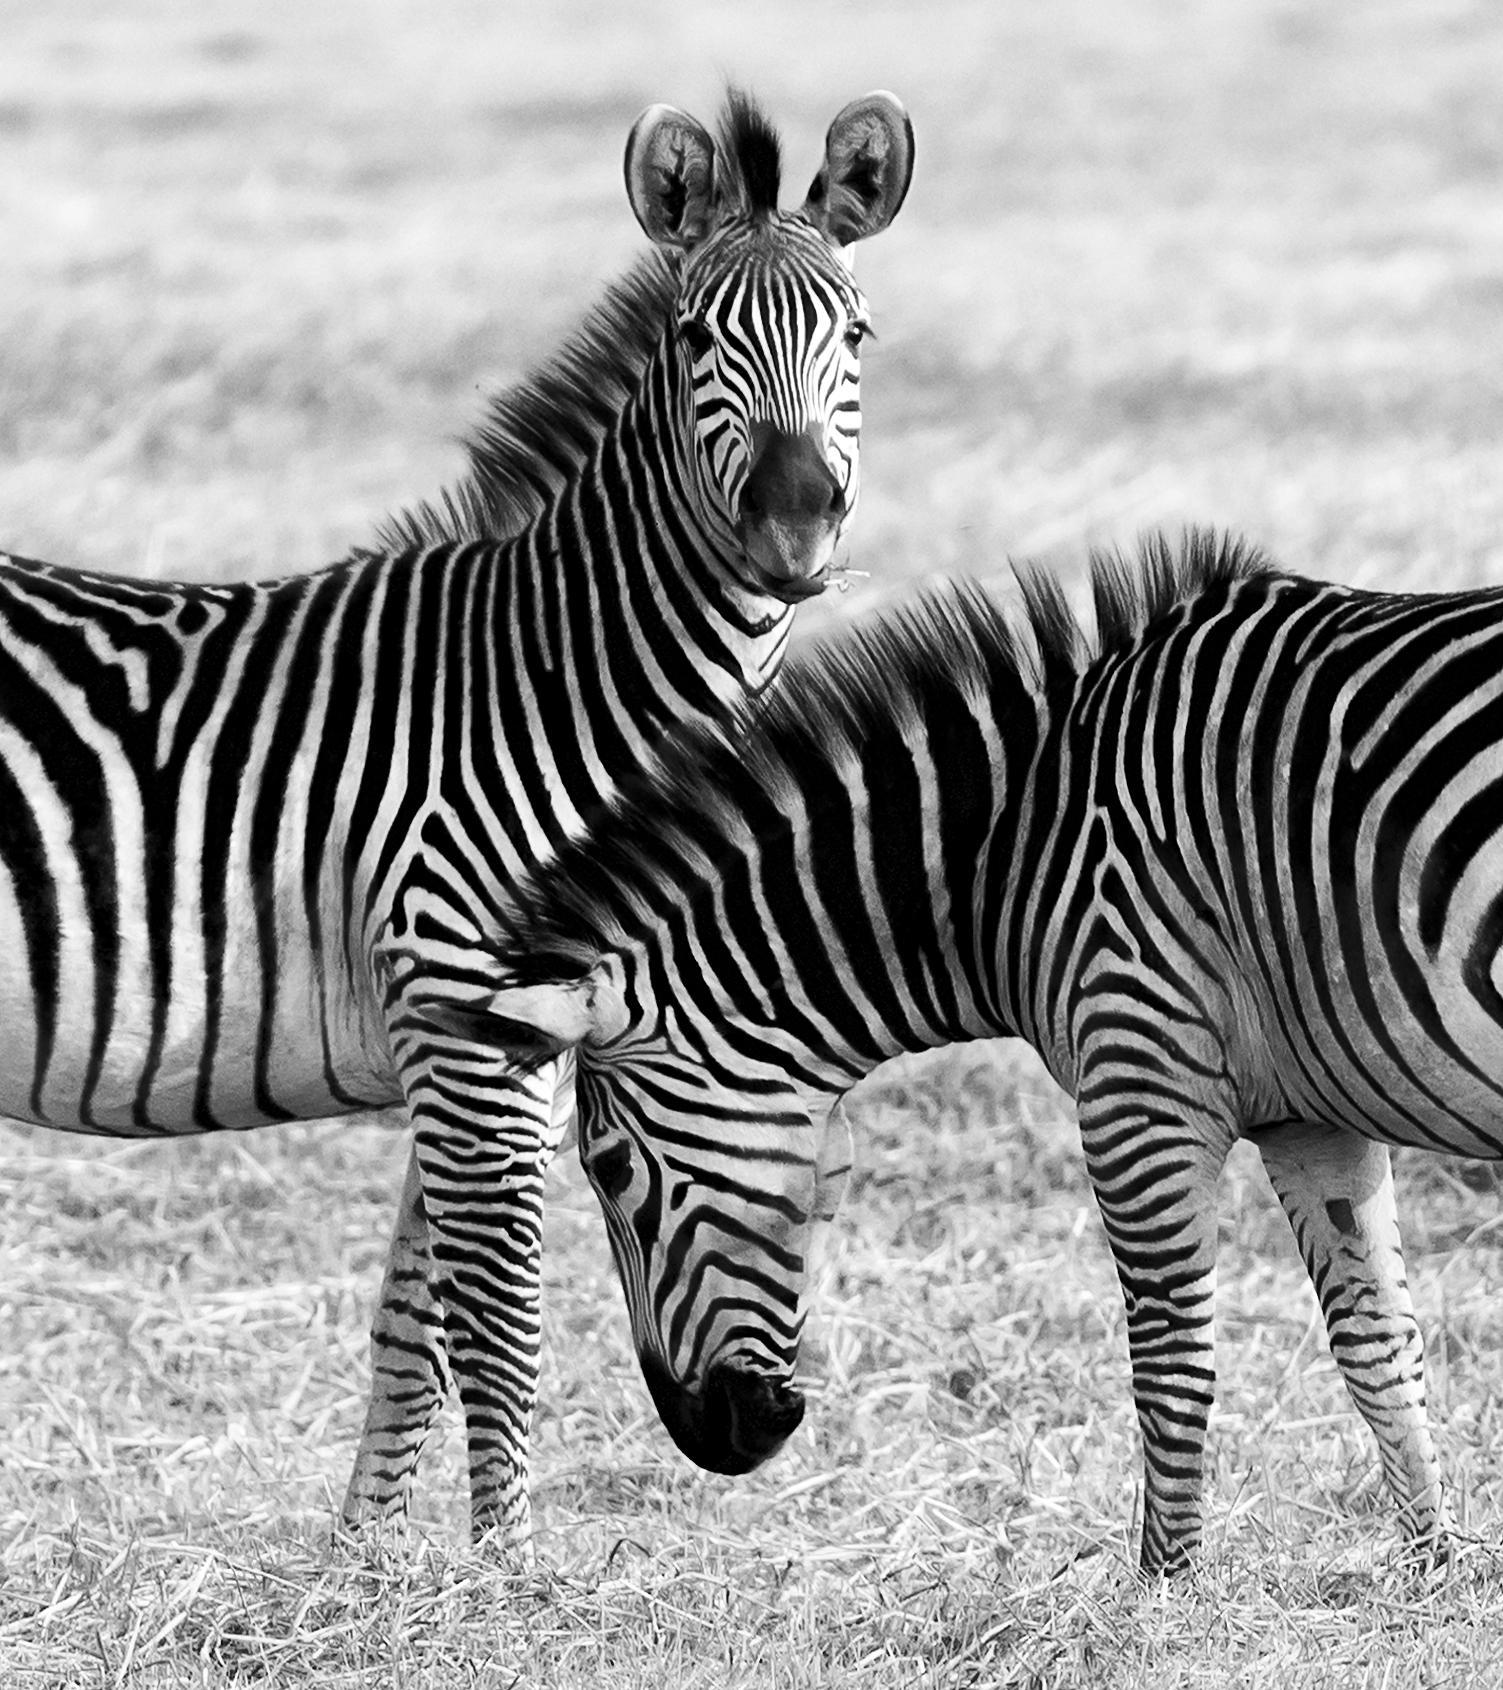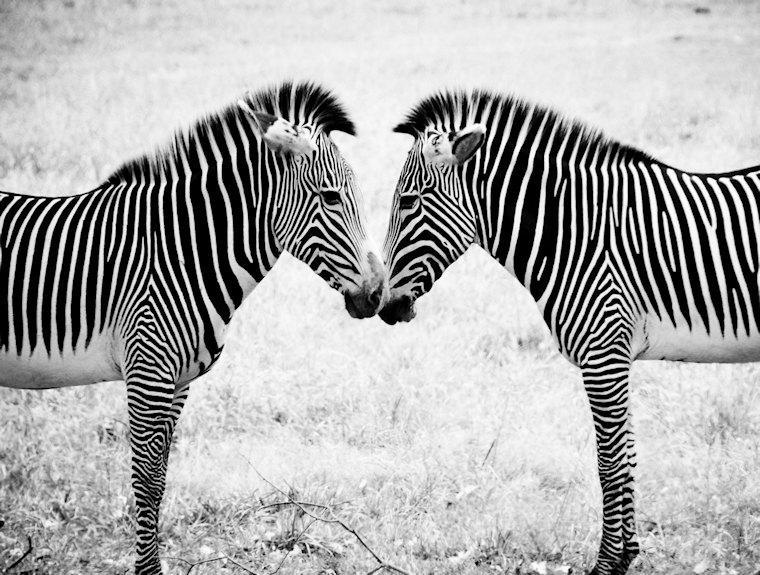The first image is the image on the left, the second image is the image on the right. Analyze the images presented: Is the assertion "Two standing zebras whose heads are parallel in height have their bodies turned toward each other in the right image." valid? Answer yes or no. Yes. The first image is the image on the left, the second image is the image on the right. Given the left and right images, does the statement "Both images have the same number of zebras." hold true? Answer yes or no. Yes. 